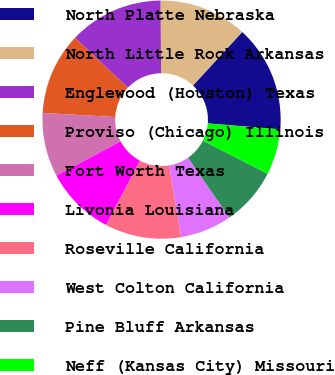<chart> <loc_0><loc_0><loc_500><loc_500><pie_chart><fcel>North Platte Nebraska<fcel>North Little Rock Arkansas<fcel>Englewood (Houston) Texas<fcel>Proviso (Chicago) Illinois<fcel>Fort Worth Texas<fcel>Livonia Louisiana<fcel>Roseville California<fcel>West Colton California<fcel>Pine Bluff Arkansas<fcel>Neff (Kansas City) Missouri<nl><fcel>14.46%<fcel>11.98%<fcel>12.81%<fcel>11.16%<fcel>8.68%<fcel>9.5%<fcel>10.33%<fcel>7.02%<fcel>7.85%<fcel>6.2%<nl></chart> 